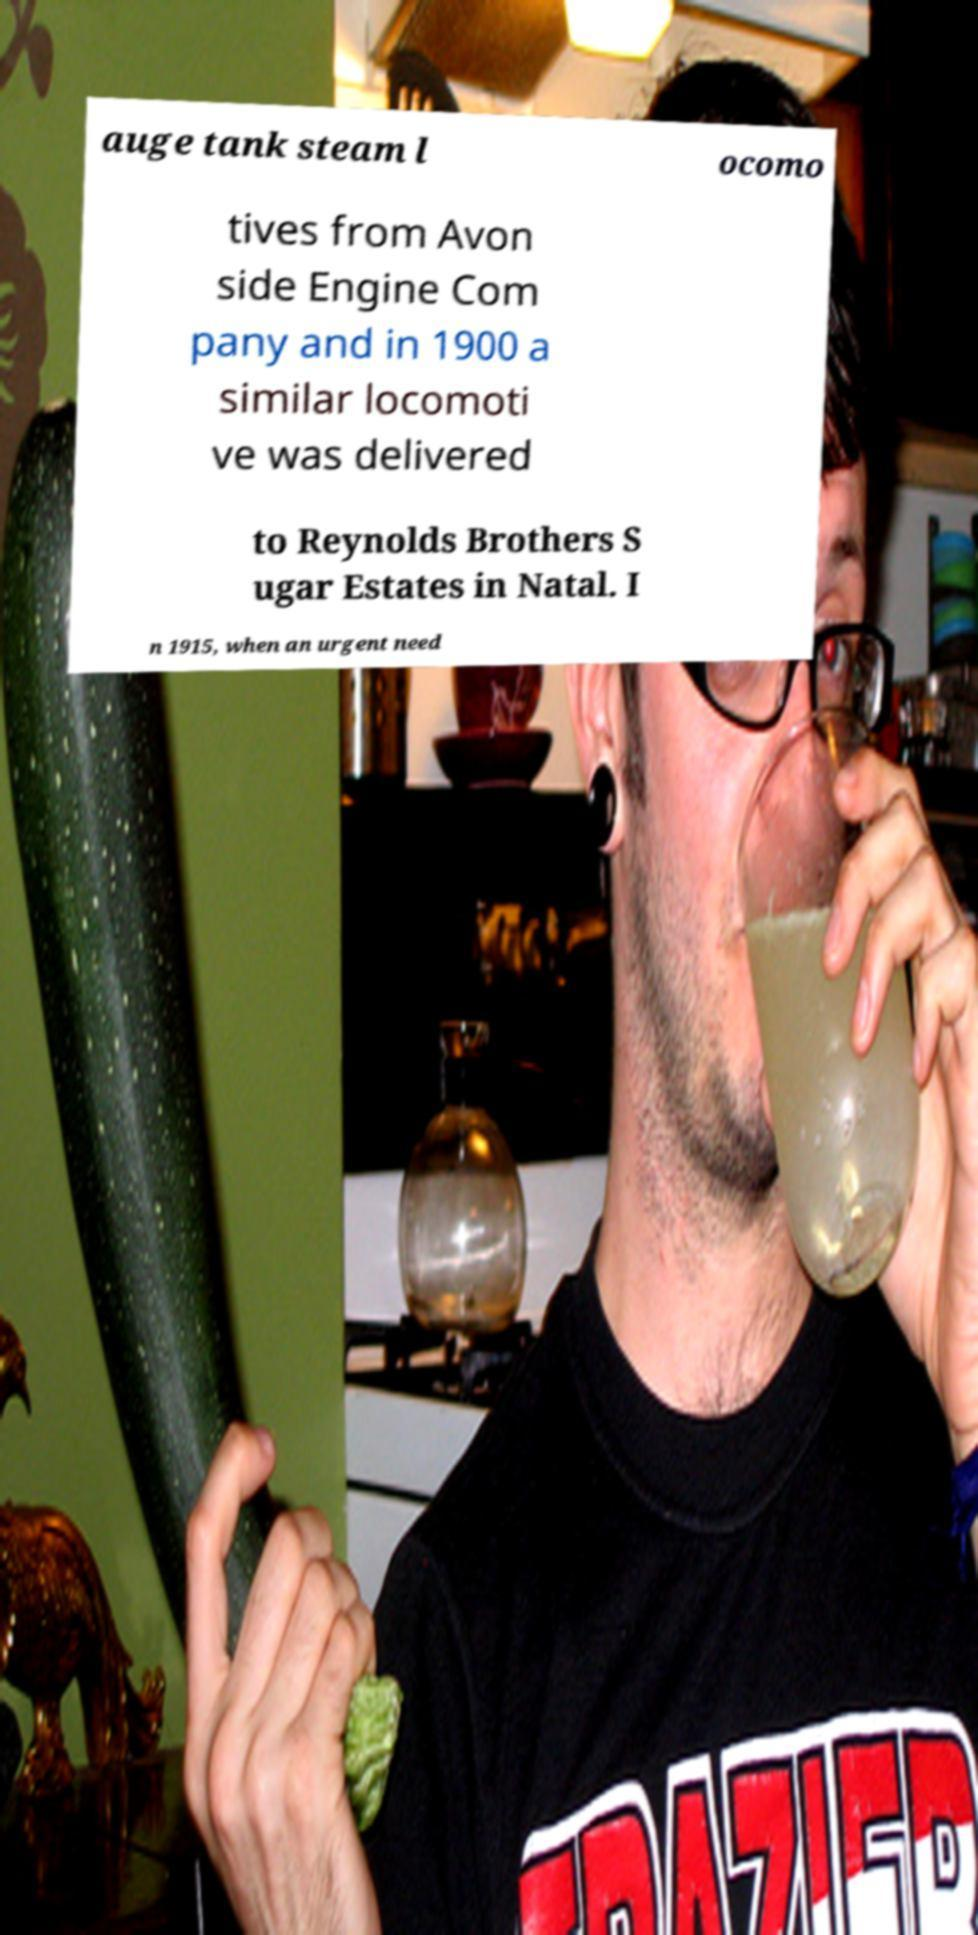Please identify and transcribe the text found in this image. auge tank steam l ocomo tives from Avon side Engine Com pany and in 1900 a similar locomoti ve was delivered to Reynolds Brothers S ugar Estates in Natal. I n 1915, when an urgent need 